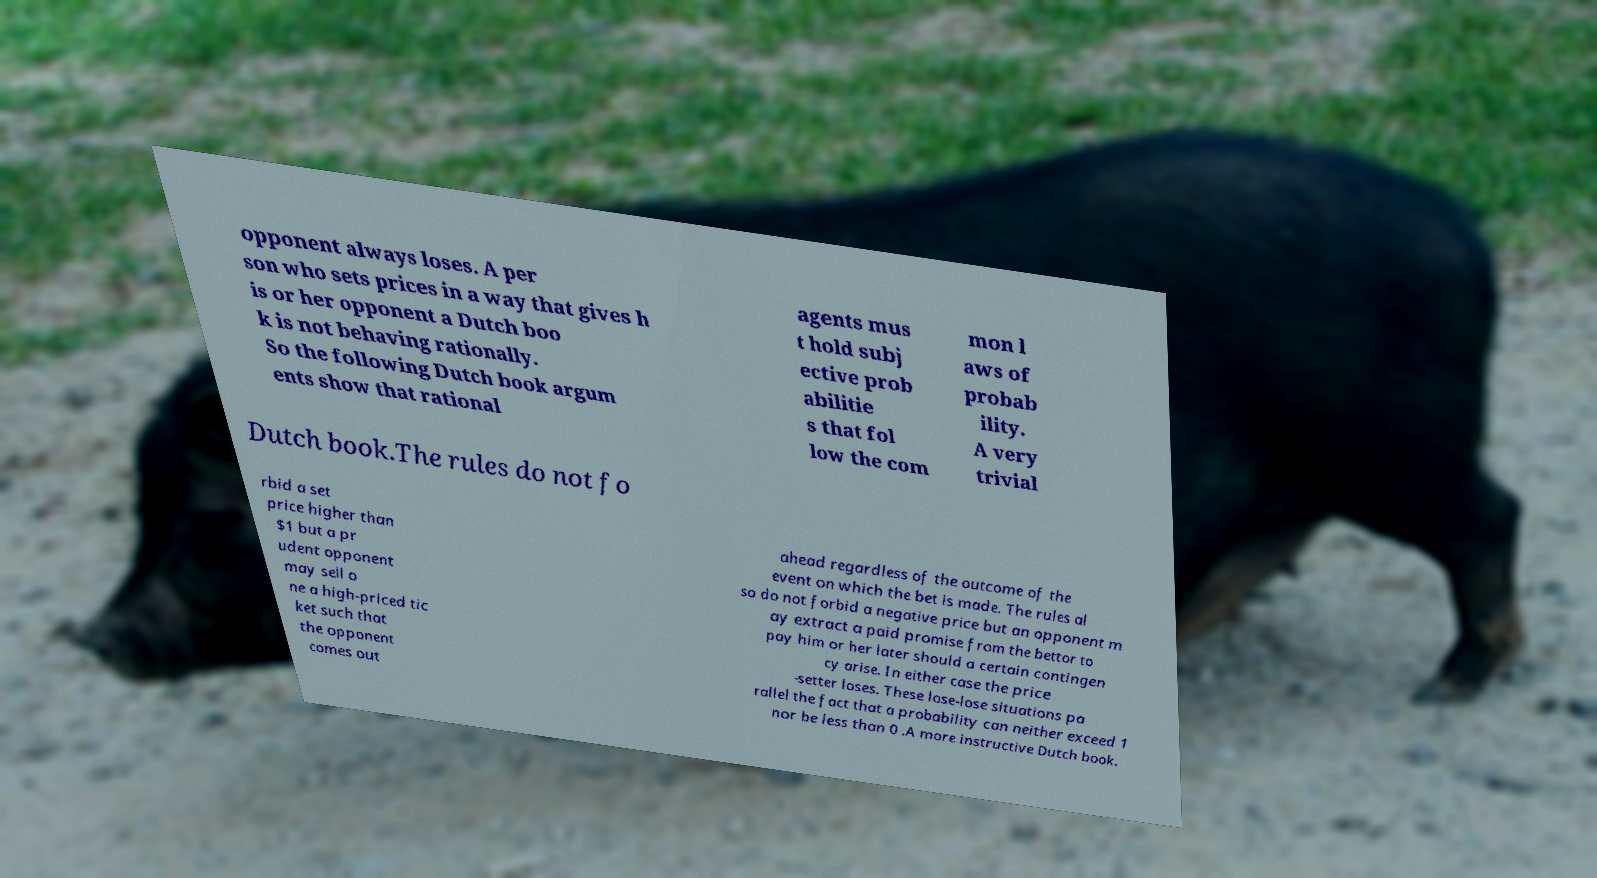Can you read and provide the text displayed in the image?This photo seems to have some interesting text. Can you extract and type it out for me? opponent always loses. A per son who sets prices in a way that gives h is or her opponent a Dutch boo k is not behaving rationally. So the following Dutch book argum ents show that rational agents mus t hold subj ective prob abilitie s that fol low the com mon l aws of probab ility. A very trivial Dutch book.The rules do not fo rbid a set price higher than $1 but a pr udent opponent may sell o ne a high-priced tic ket such that the opponent comes out ahead regardless of the outcome of the event on which the bet is made. The rules al so do not forbid a negative price but an opponent m ay extract a paid promise from the bettor to pay him or her later should a certain contingen cy arise. In either case the price -setter loses. These lose-lose situations pa rallel the fact that a probability can neither exceed 1 nor be less than 0 .A more instructive Dutch book. 